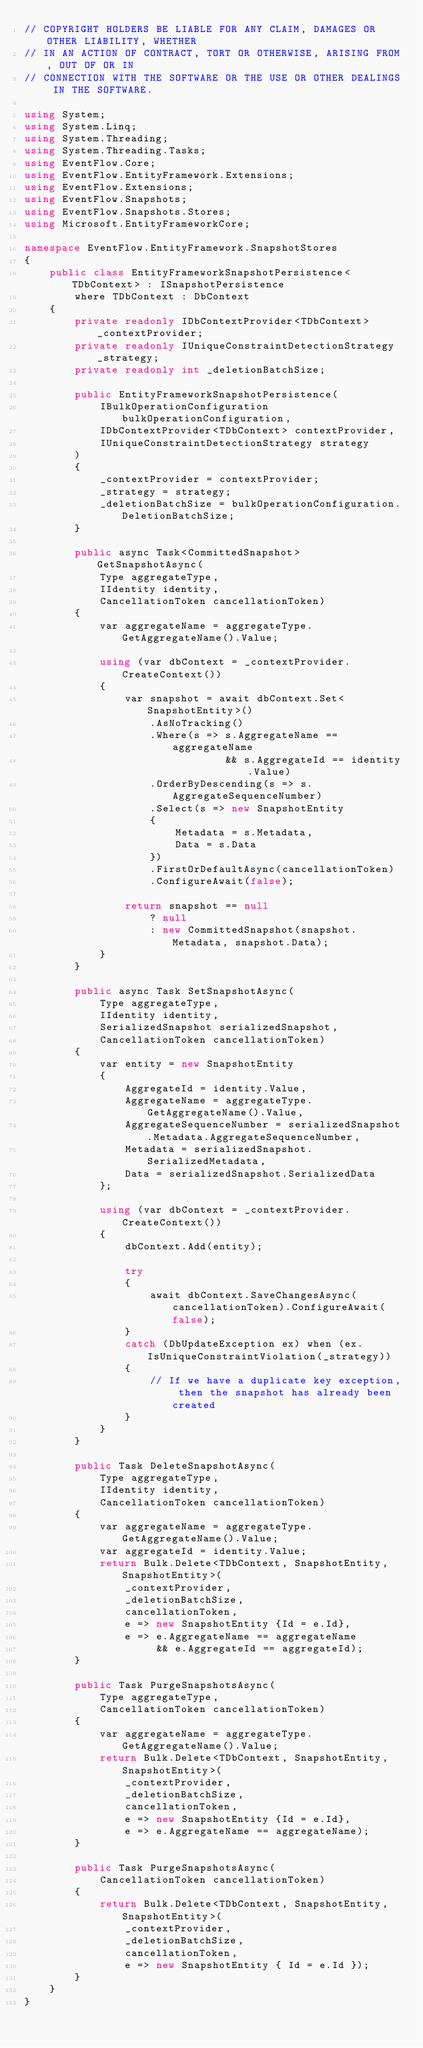<code> <loc_0><loc_0><loc_500><loc_500><_C#_>// COPYRIGHT HOLDERS BE LIABLE FOR ANY CLAIM, DAMAGES OR OTHER LIABILITY, WHETHER
// IN AN ACTION OF CONTRACT, TORT OR OTHERWISE, ARISING FROM, OUT OF OR IN
// CONNECTION WITH THE SOFTWARE OR THE USE OR OTHER DEALINGS IN THE SOFTWARE.

using System;
using System.Linq;
using System.Threading;
using System.Threading.Tasks;
using EventFlow.Core;
using EventFlow.EntityFramework.Extensions;
using EventFlow.Extensions;
using EventFlow.Snapshots;
using EventFlow.Snapshots.Stores;
using Microsoft.EntityFrameworkCore;

namespace EventFlow.EntityFramework.SnapshotStores
{
    public class EntityFrameworkSnapshotPersistence<TDbContext> : ISnapshotPersistence
        where TDbContext : DbContext
    {
        private readonly IDbContextProvider<TDbContext> _contextProvider;
        private readonly IUniqueConstraintDetectionStrategy _strategy;
        private readonly int _deletionBatchSize;

        public EntityFrameworkSnapshotPersistence(
            IBulkOperationConfiguration bulkOperationConfiguration,
            IDbContextProvider<TDbContext> contextProvider,
            IUniqueConstraintDetectionStrategy strategy
        )
        {
            _contextProvider = contextProvider;
            _strategy = strategy;
            _deletionBatchSize = bulkOperationConfiguration.DeletionBatchSize;
        }

        public async Task<CommittedSnapshot> GetSnapshotAsync(
            Type aggregateType,
            IIdentity identity,
            CancellationToken cancellationToken)
        {
            var aggregateName = aggregateType.GetAggregateName().Value;

            using (var dbContext = _contextProvider.CreateContext())
            {
                var snapshot = await dbContext.Set<SnapshotEntity>()
                    .AsNoTracking()
                    .Where(s => s.AggregateName == aggregateName
                                && s.AggregateId == identity.Value)
                    .OrderByDescending(s => s.AggregateSequenceNumber)
                    .Select(s => new SnapshotEntity
                    {
                        Metadata = s.Metadata,
                        Data = s.Data
                    })
                    .FirstOrDefaultAsync(cancellationToken)
                    .ConfigureAwait(false);

                return snapshot == null 
                    ? null 
                    : new CommittedSnapshot(snapshot.Metadata, snapshot.Data);
            }
        }

        public async Task SetSnapshotAsync(
            Type aggregateType,
            IIdentity identity,
            SerializedSnapshot serializedSnapshot,
            CancellationToken cancellationToken)
        {
            var entity = new SnapshotEntity
            {
                AggregateId = identity.Value,
                AggregateName = aggregateType.GetAggregateName().Value,
                AggregateSequenceNumber = serializedSnapshot.Metadata.AggregateSequenceNumber,
                Metadata = serializedSnapshot.SerializedMetadata,
                Data = serializedSnapshot.SerializedData
            };

            using (var dbContext = _contextProvider.CreateContext())
            {
                dbContext.Add(entity);

                try
                {
                    await dbContext.SaveChangesAsync(cancellationToken).ConfigureAwait(false);
                }
                catch (DbUpdateException ex) when (ex.IsUniqueConstraintViolation(_strategy))
                {
                    // If we have a duplicate key exception, then the snapshot has already been created
                }
            }
        }

        public Task DeleteSnapshotAsync(
            Type aggregateType,
            IIdentity identity,
            CancellationToken cancellationToken)
        {
            var aggregateName = aggregateType.GetAggregateName().Value;
            var aggregateId = identity.Value;
            return Bulk.Delete<TDbContext, SnapshotEntity, SnapshotEntity>(
                _contextProvider,
                _deletionBatchSize,
                cancellationToken,
                e => new SnapshotEntity {Id = e.Id},
                e => e.AggregateName == aggregateName
                     && e.AggregateId == aggregateId);
        }

        public Task PurgeSnapshotsAsync(
            Type aggregateType,
            CancellationToken cancellationToken)
        {
            var aggregateName = aggregateType.GetAggregateName().Value;
            return Bulk.Delete<TDbContext, SnapshotEntity, SnapshotEntity>(
                _contextProvider,
                _deletionBatchSize,
                cancellationToken,
                e => new SnapshotEntity {Id = e.Id},
                e => e.AggregateName == aggregateName);
        }

        public Task PurgeSnapshotsAsync(
            CancellationToken cancellationToken)
        {
            return Bulk.Delete<TDbContext, SnapshotEntity, SnapshotEntity>(
                _contextProvider,
                _deletionBatchSize,
                cancellationToken, 
                e => new SnapshotEntity { Id = e.Id });
        }
    }
}

</code> 